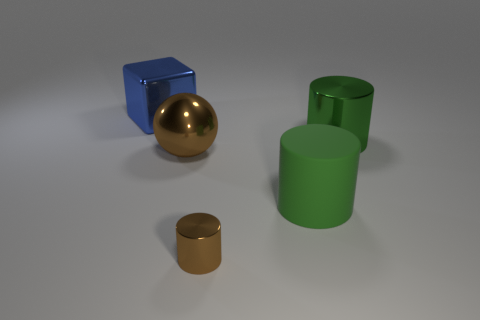Is there anything else that has the same size as the brown cylinder?
Make the answer very short. No. How many large balls are on the right side of the big green shiny cylinder behind the big thing in front of the large brown metal object?
Provide a succinct answer. 0. Is there a matte thing that has the same size as the green metal object?
Give a very brief answer. Yes. Is the number of brown things that are in front of the tiny object less than the number of small gray metallic balls?
Ensure brevity in your answer.  No. There is a green object that is in front of the big metal thing in front of the large green thing that is behind the large green matte cylinder; what is its material?
Your answer should be compact. Rubber. Is the number of shiny things behind the brown metallic cylinder greater than the number of big brown things that are in front of the large sphere?
Your response must be concise. Yes. How many metal things are either large blocks or brown cylinders?
Your answer should be compact. 2. What shape is the other metallic thing that is the same color as the small object?
Your answer should be compact. Sphere. There is a thing behind the big green metal cylinder; what material is it?
Your answer should be compact. Metal. How many things are either metallic cubes or things that are right of the small brown object?
Provide a short and direct response. 3. 